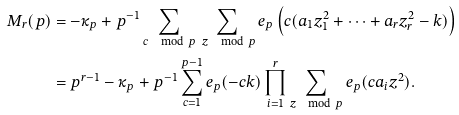Convert formula to latex. <formula><loc_0><loc_0><loc_500><loc_500>M _ { r } ( p ) & = - \kappa _ { p } + { p ^ { - 1 } } \sum _ { c \mod p } \sum _ { \ z \mod { p } } e _ { p } \left ( c ( a _ { 1 } z _ { 1 } ^ { 2 } + \cdots + a _ { r } z _ { r } ^ { 2 } - k ) \right ) \\ & = p ^ { r - 1 } - \kappa _ { p } + p ^ { - 1 } \sum _ { c = 1 } ^ { p - 1 } e _ { p } ( - c k ) \prod _ { i = 1 } ^ { r } \sum _ { z \mod { p } } e _ { p } ( c a _ { i } z ^ { 2 } ) .</formula> 